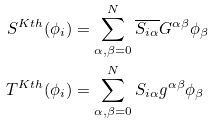<formula> <loc_0><loc_0><loc_500><loc_500>S ^ { K t h } ( \phi _ { i } ) & = \sum _ { \alpha , \beta = 0 } ^ { N } \overline { S _ { i \alpha } } G ^ { \alpha \beta } \phi _ { \beta } \\ T ^ { K t h } ( \phi _ { i } ) & = \sum _ { \alpha , \beta = 0 } ^ { N } S _ { i \alpha } g ^ { \alpha \beta } \phi _ { \beta }</formula> 